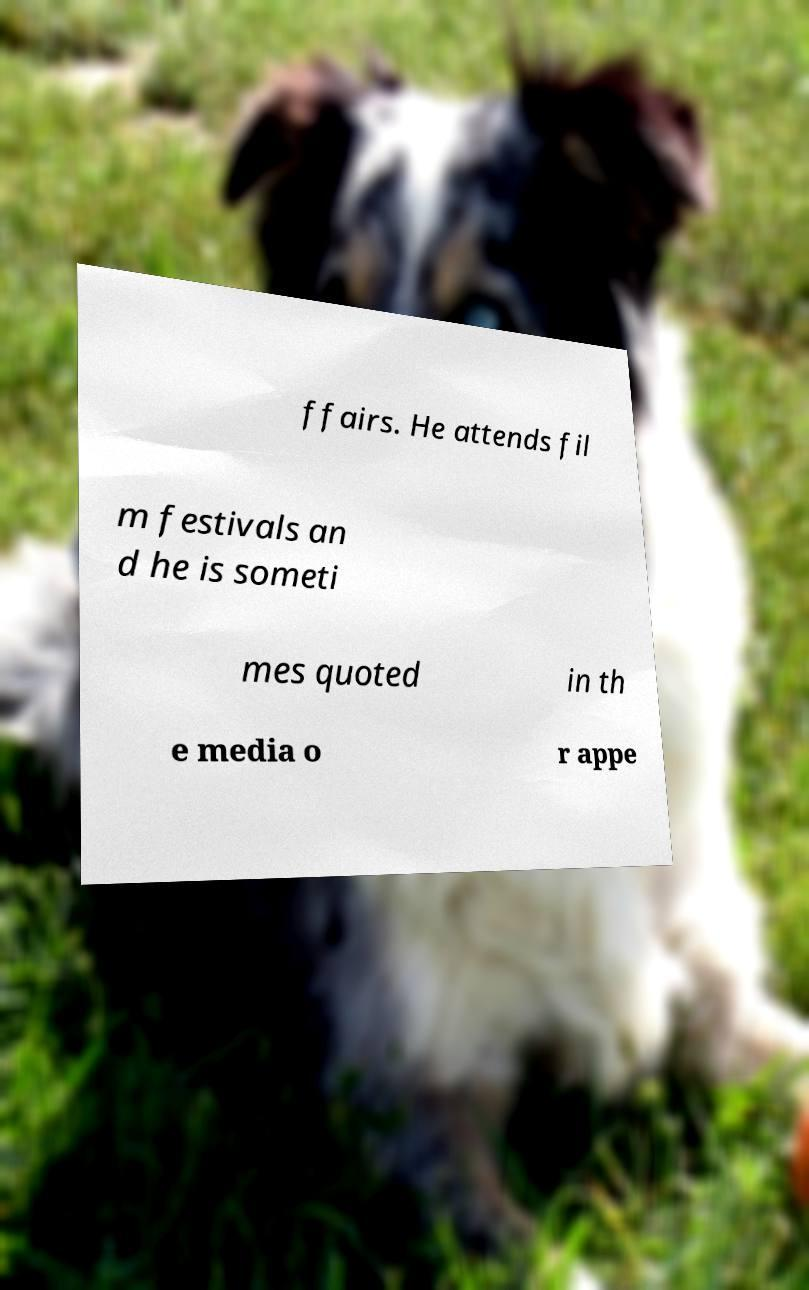Please identify and transcribe the text found in this image. ffairs. He attends fil m festivals an d he is someti mes quoted in th e media o r appe 